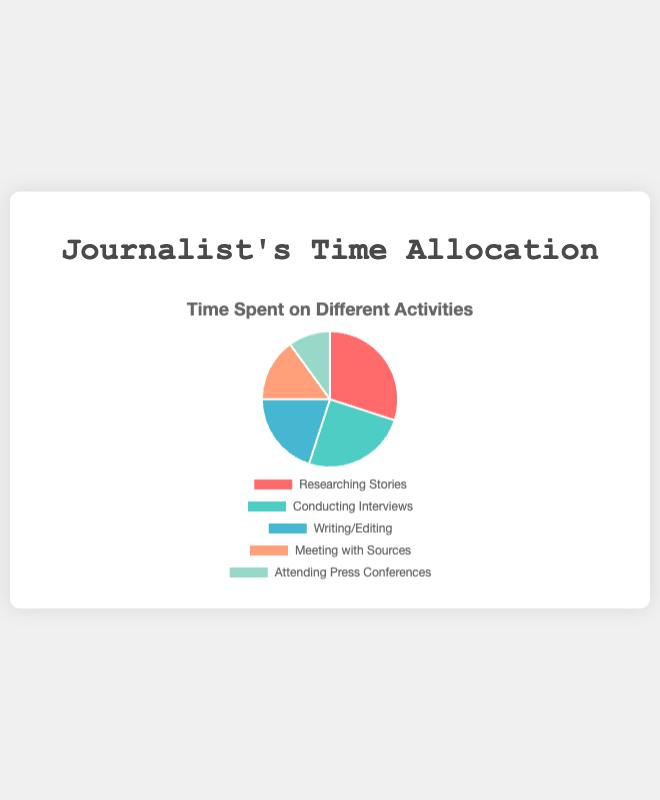What is the largest category in the pie chart? To identify the largest category, look for the section of the pie chart that occupies the greatest area. The slice labeled "Researching Stories" appears to be the largest, accounting for 30%.
Answer: Researching Stories Which category occupies the smallest percentage of time? To determine the smallest category, identify the section of the pie chart with the smallest area. The slice labeled "Attending Press Conferences" is the smallest, representing 10% of the time.
Answer: Attending Press Conferences How much more time is spent on "Researching Stories" compared to "Meeting with Sources"? Look at the percentage values for both categories: "Researching Stories" is 30% and "Meeting with Sources" is 15%. Subtract the smaller percentage from the larger one: 30% - 15% = 15%.
Answer: 15% What is the total percentage of time spent on "Conducting Interviews" and "Writing/Editing" combined? To find this, add the percentages for "Conducting Interviews" (25%) and "Writing/Editing" (20%): 25% + 20% = 45%.
Answer: 45% What is the average percentage of time spent on all the activities? Add all the percentages for each activity: 30% + 25% + 20% + 15% + 10% = 100%. Since there are 5 categories, divide the total by 5: 100% / 5 = 20%.
Answer: 20% If "Researching Stories" and "Conducting Interviews" together represent 55%, what fraction of the remaining time is spent "Writing/Editing"? First, sum "Researching Stories" and "Conducting Interviews" to get 55%, leaving 45% for the other activities. Then, find the "Writing/Editing" percentage, which is 20%. The fraction is 20% of 45% = 20 / 45 = 4 / 9.
Answer: 4/9 Among "Writing/Editing" and "Meeting with Sources", which activity occupies a greater percentage of time and by how much? Compare the given percentages of "Writing/Editing" (20%) and "Meeting with Sources" (15%). Subtract the smaller percentage from the larger one to find the difference: 20% - 15% = 5%.
Answer: Writing/Editing by 5% What colors are used to represent "Conducting Interviews" and "Attending Press Conferences" in the pie chart? Visually identify the colors associated with the corresponding labels. "Conducting Interviews" is represented by a greenish color and "Attending Press Conferences" is represented by a light blue color.
Answer: Greenish color for Conducting Interviews, Light blue color for Attending Press Conferences Is the time spent on "Meeting with Sources" greater than or less than half the time spent on "Researching Stories"? Check the percentage for "Meeting with Sources" (15%) and compare it with half of the percentage for "Researching Stories" (30% / 2 = 15%). Since they are equal, "Meeting with Sources" is exactly half the time spent on "Researching Stories".
Answer: Equal 